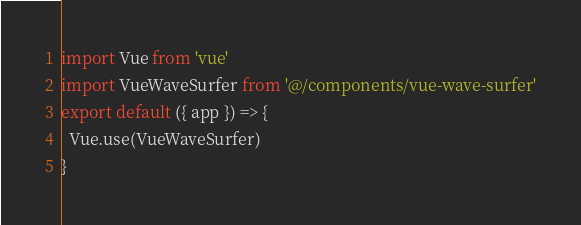Convert code to text. <code><loc_0><loc_0><loc_500><loc_500><_JavaScript_>import Vue from 'vue'
import VueWaveSurfer from '@/components/vue-wave-surfer'
export default ({ app }) => {
  Vue.use(VueWaveSurfer)
}
</code> 